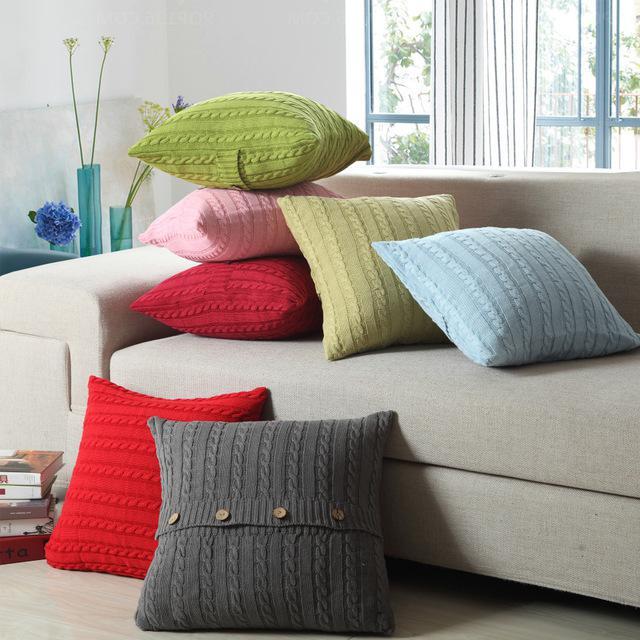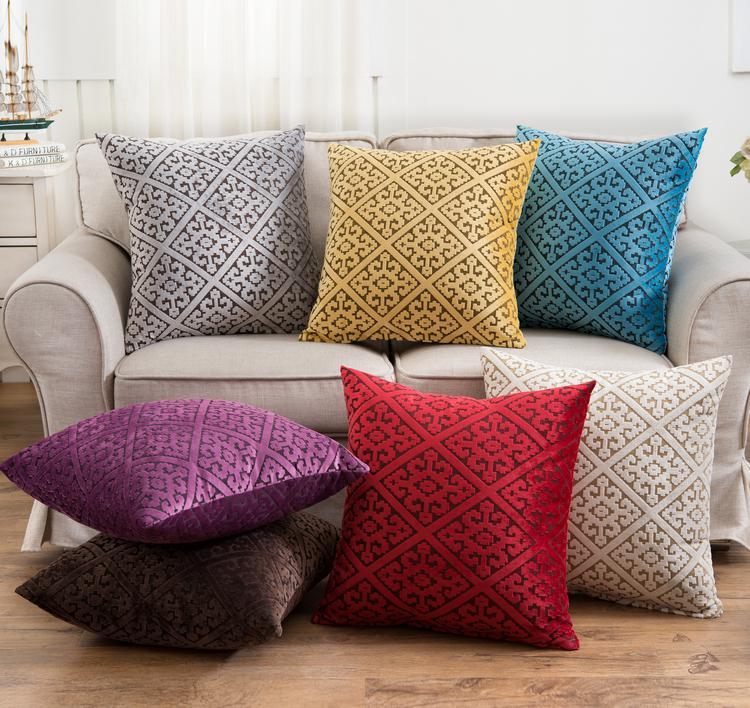The first image is the image on the left, the second image is the image on the right. Given the left and right images, does the statement "Two different colored pillows are stacked horizontally on a floor beside no more than two other different colored pillows." hold true? Answer yes or no. Yes. The first image is the image on the left, the second image is the image on the right. Given the left and right images, does the statement "One image features at least one pillow with button closures, and the other image contains at least 7 square pillows of different colors." hold true? Answer yes or no. Yes. 